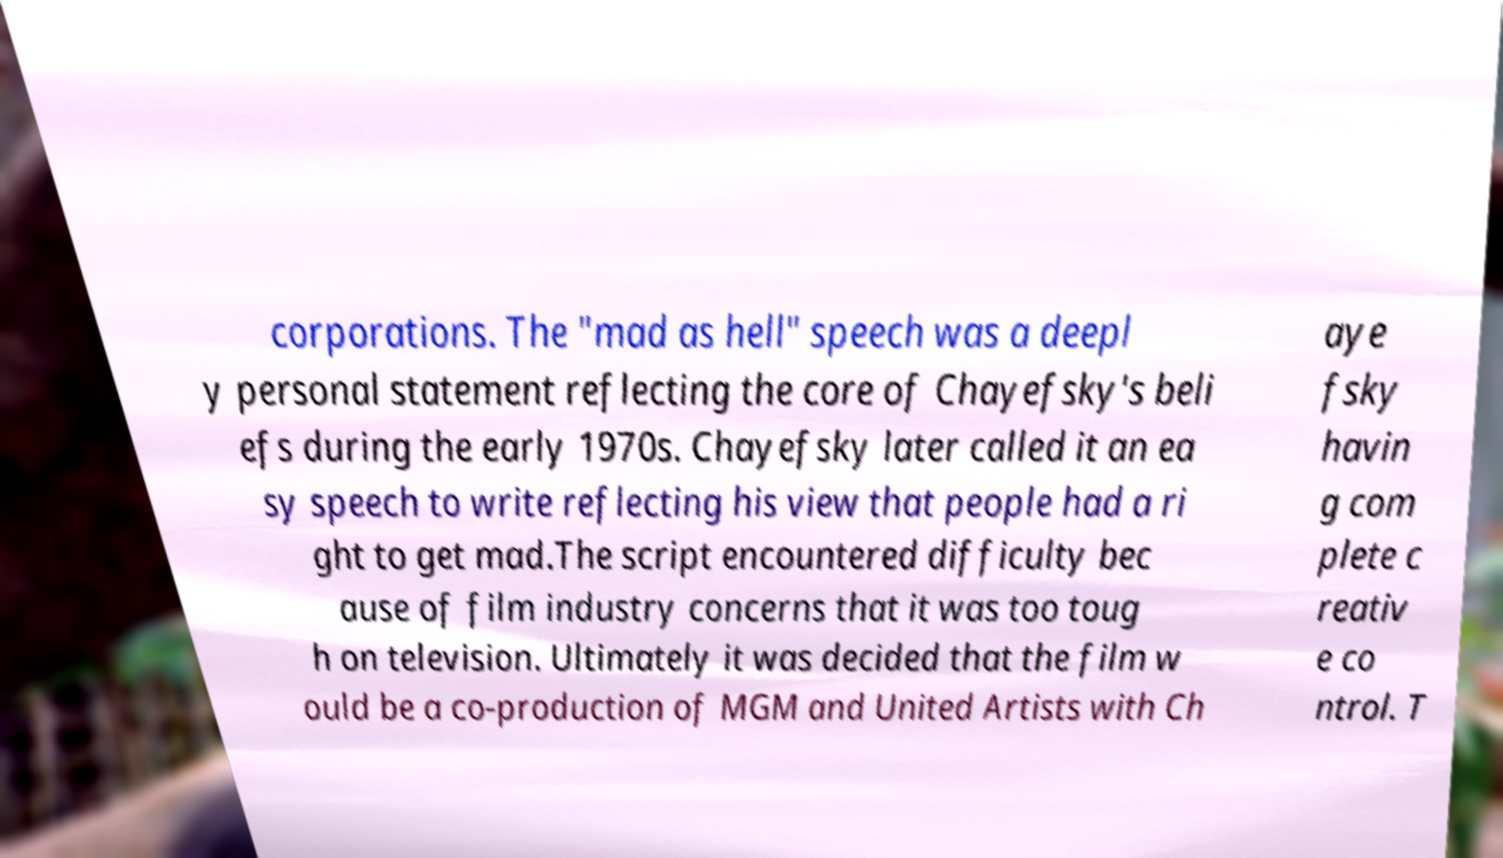Can you read and provide the text displayed in the image?This photo seems to have some interesting text. Can you extract and type it out for me? corporations. The "mad as hell" speech was a deepl y personal statement reflecting the core of Chayefsky's beli efs during the early 1970s. Chayefsky later called it an ea sy speech to write reflecting his view that people had a ri ght to get mad.The script encountered difficulty bec ause of film industry concerns that it was too toug h on television. Ultimately it was decided that the film w ould be a co-production of MGM and United Artists with Ch aye fsky havin g com plete c reativ e co ntrol. T 